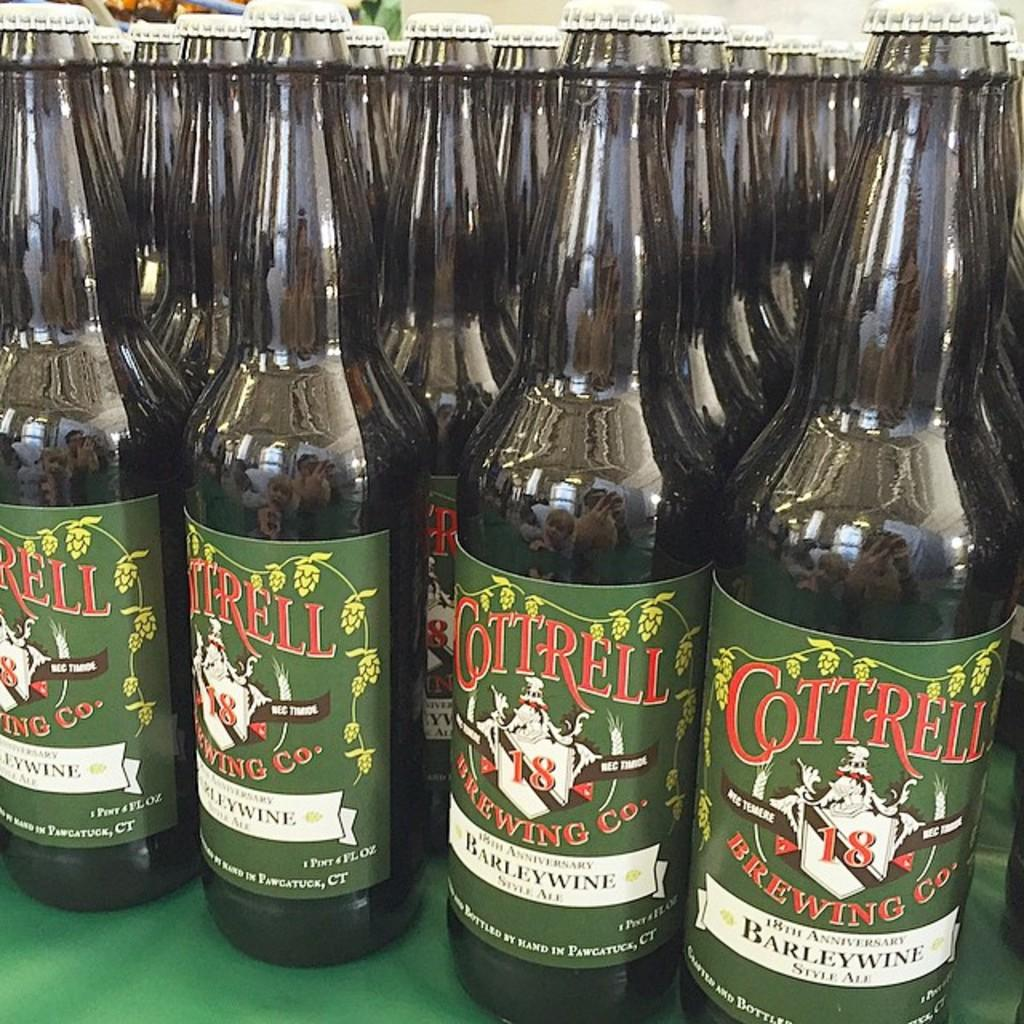Provide a one-sentence caption for the provided image. Beer bottles that have a label saying Cottrell on it. 